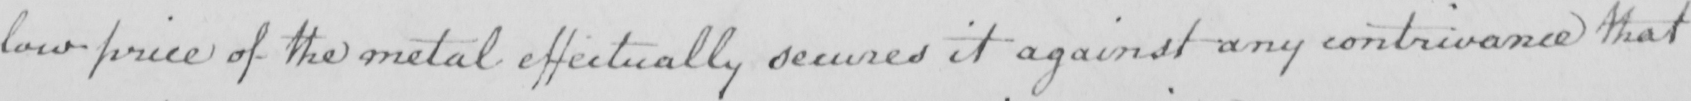What is written in this line of handwriting? low price of the metal effectually secures it against any contrivance that 